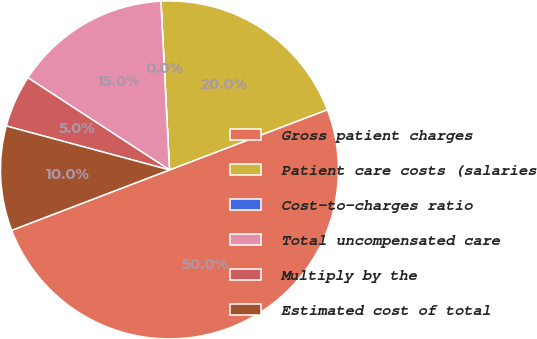Convert chart to OTSL. <chart><loc_0><loc_0><loc_500><loc_500><pie_chart><fcel>Gross patient charges<fcel>Patient care costs (salaries<fcel>Cost-to-charges ratio<fcel>Total uncompensated care<fcel>Multiply by the<fcel>Estimated cost of total<nl><fcel>49.99%<fcel>20.0%<fcel>0.01%<fcel>15.0%<fcel>5.0%<fcel>10.0%<nl></chart> 